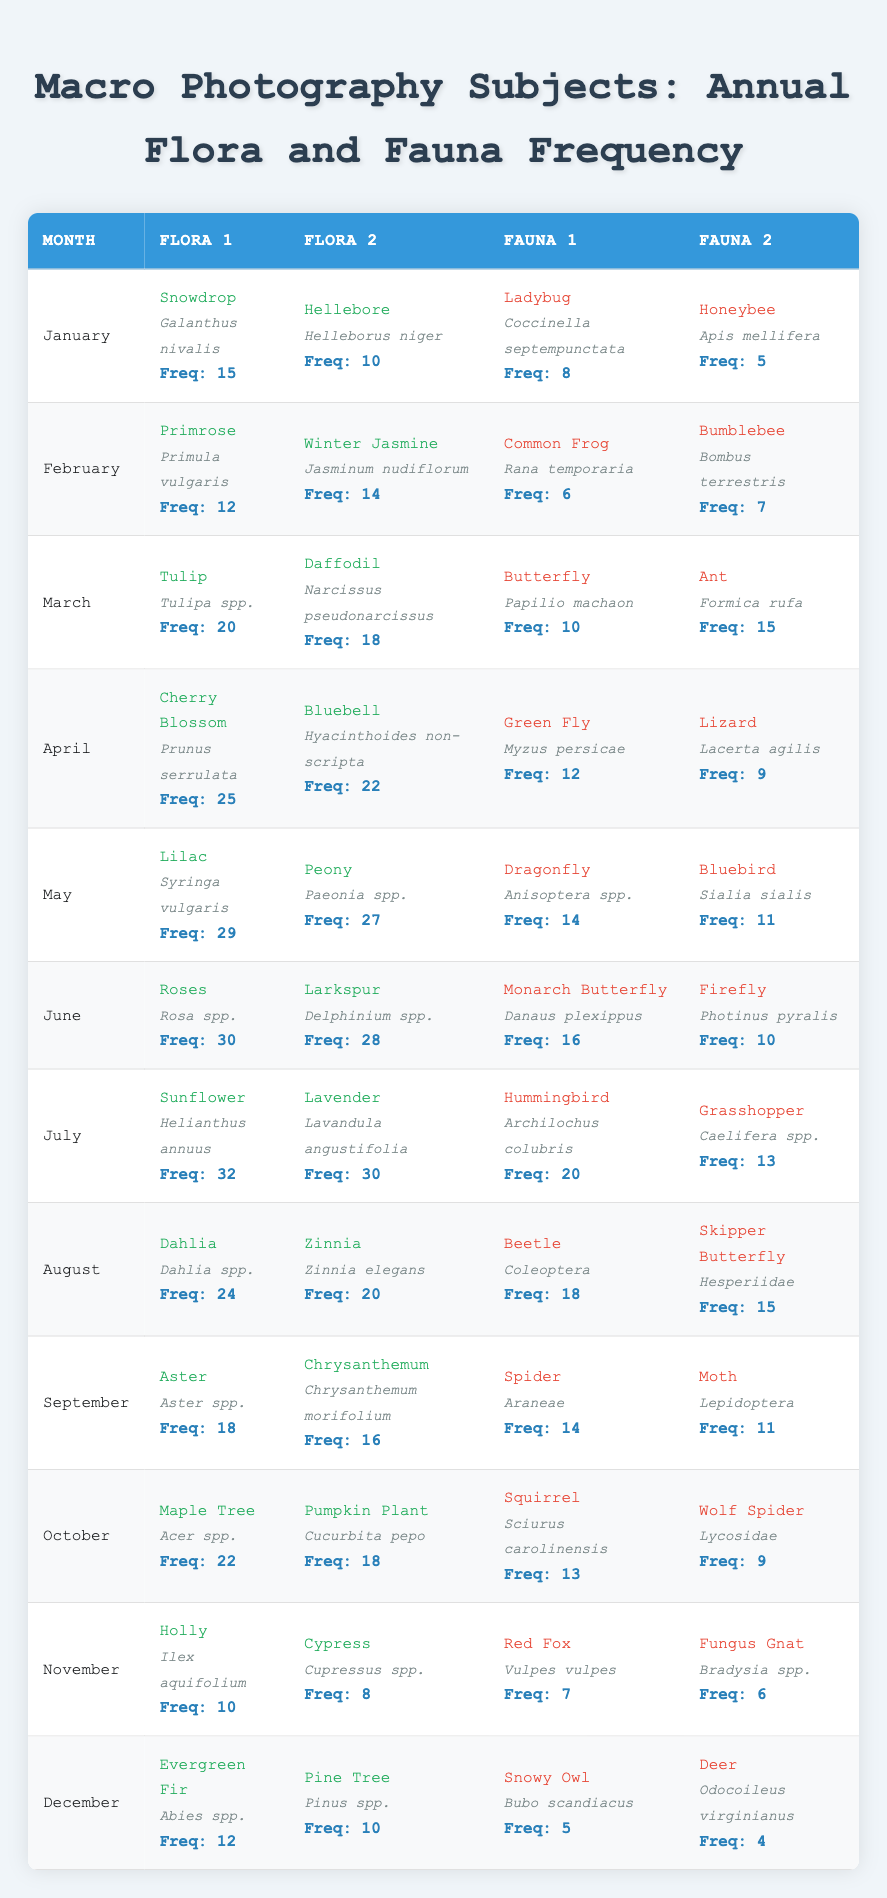What is the most frequently captured flora in July? According to the table, the flora captured in July includes Sunflower (32) and Lavender (30). Sunflower has the highest frequency at 32.
Answer: Sunflower Which month had the least frequency of fauna captured? The fauna captured in November includes Red Fox (7) and Fungus Gnat (6), with Fungus Gnat having the lowest frequency at 6.
Answer: November What is the total frequency of flora captured in September? In September, Aster has a frequency of 18 and Chrysanthemum has a frequency of 16. Adding these gives us 18 + 16 = 34.
Answer: 34 Is the frequency of Daffodil higher than that of Ladybug? Daffodil has a frequency of 18, while Ladybug has a frequency of 8. Since 18 is greater than 8, the statement is true.
Answer: Yes Which month has the highest total frequency of both flora and fauna combined? We can calculate the total frequency for each month. For example, in April we have 25 (Cherry Blossom) + 22 (Bluebell) + 12 (Green Fly) + 9 (Lizard) = 68. After calculating for each month, we find that July has a total of 32 (Sunflower) + 30 (Lavender) + 20 (Hummingbird) + 13 (Grasshopper) = 95, which is the highest total.
Answer: July What is the difference in frequency between the most captured fauna in June and the least captured fauna in December? In June, Monarch Butterfly has a frequency of 16, while in December, Deer has a frequency of 4. The difference is 16 - 4 = 12.
Answer: 12 Which two months had the same frequency of fauna captured? By comparing the total frequencies of fauna monthly, we find that February (13) and October (13) have the same total frequency of fauna captured.
Answer: February and October What percentage of the total fauna frequency in March is made up by Ant? The total fauna frequency in March is 10 (Butterfly) + 15 (Ant) = 25. Therefore, the percentage of Ant is (15/25) * 100 = 60%.
Answer: 60% How many different types of flora were captured in the year? The table lists 24 unique flora entries across all months. Each month contributes two different types of flora, thus 12 (months) x 2 = 24.
Answer: 24 Which fauna has a higher frequency: Bluebird in May or Hummingbird in July? Bluebird has a frequency of 11, while Hummingbird has a frequency of 20. Since 20 is greater than 11, Hummingbird has a higher frequency.
Answer: Hummingbird Was there any fauna captured more than 20 times in the year? Looking at the table, the highest recorded fauna frequency is 20 (Hummingbird), but no fauna exceeds this frequency number.
Answer: No 